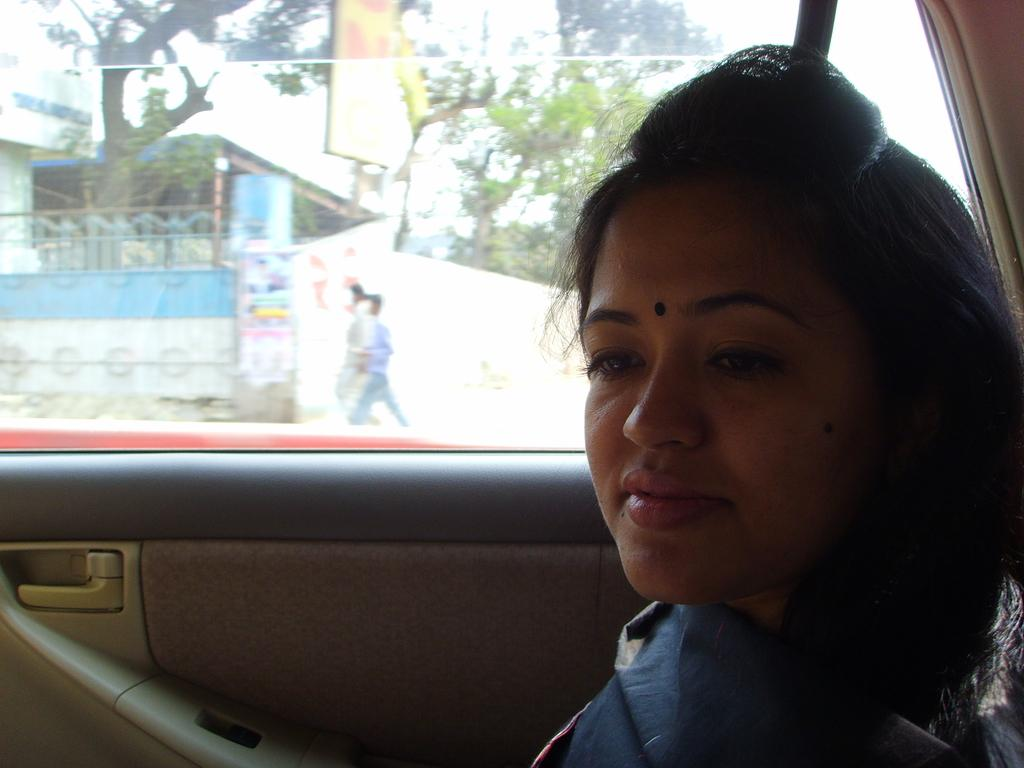Who is present in the image? There is a woman in the image. Where is the woman located in the image? The woman is sitting beside a window in a car. What can be seen through the window? There is a gate visible through the window, and there are people visible through the window as well. What type of feather can be seen on the woman's hat in the image? There is no feather present on the woman's hat in the image. What type of office supplies can be seen on the woman's desk in the image? There is no desk or office supplies present in the image; it features a woman sitting in a car. 